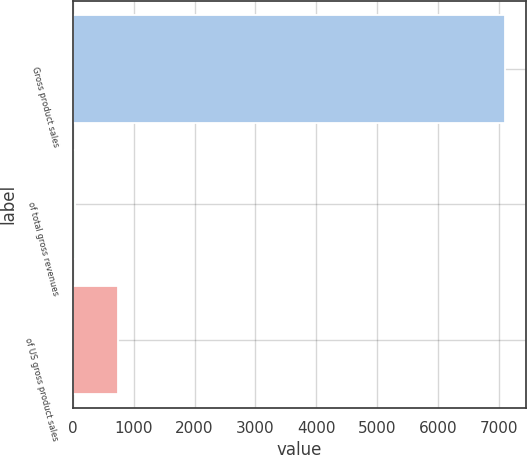<chart> <loc_0><loc_0><loc_500><loc_500><bar_chart><fcel>Gross product sales<fcel>of total gross revenues<fcel>of US gross product sales<nl><fcel>7099<fcel>37<fcel>743.2<nl></chart> 